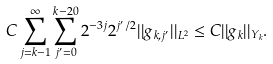<formula> <loc_0><loc_0><loc_500><loc_500>C \sum _ { j = k - 1 } ^ { \infty } \sum _ { j ^ { \prime } = 0 } ^ { k - 2 0 } 2 ^ { - 3 j } 2 ^ { j ^ { \prime } / 2 } | | g _ { k , j ^ { \prime } } | | _ { L ^ { 2 } } \leq C | | g _ { k } | | _ { Y _ { k } } .</formula> 